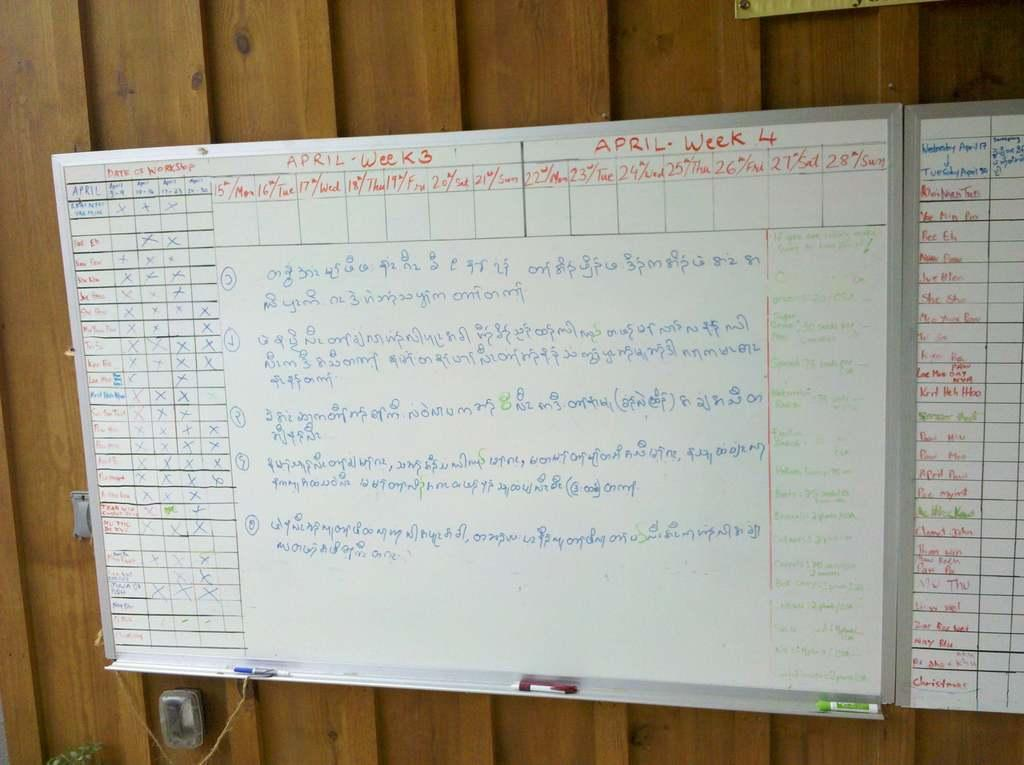<image>
Offer a succinct explanation of the picture presented. A white board says "APRIL" across the top. 